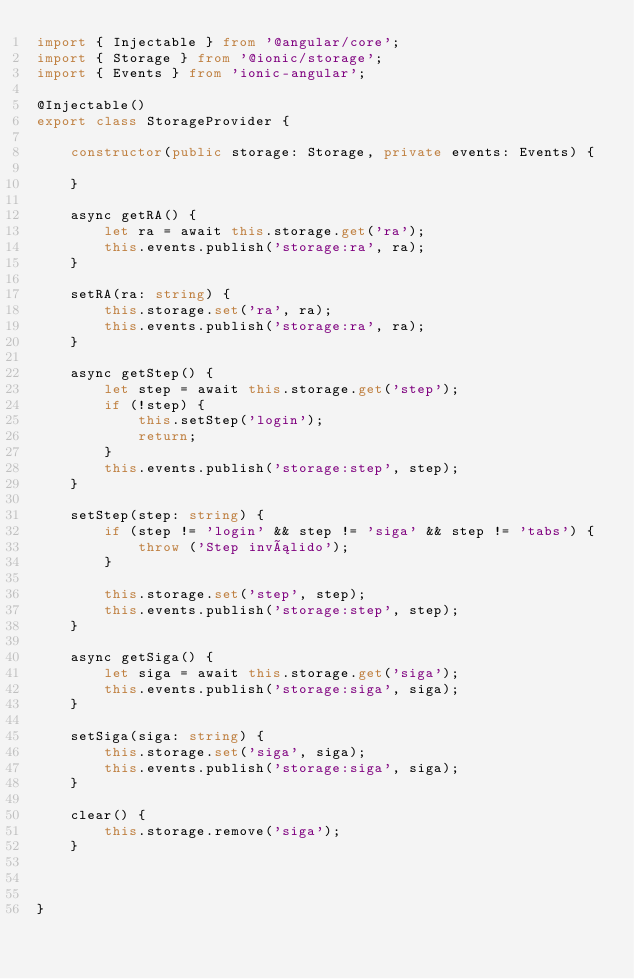<code> <loc_0><loc_0><loc_500><loc_500><_TypeScript_>import { Injectable } from '@angular/core';
import { Storage } from '@ionic/storage';
import { Events } from 'ionic-angular';

@Injectable()
export class StorageProvider {

    constructor(public storage: Storage, private events: Events) {

    }

    async getRA() {
        let ra = await this.storage.get('ra');
        this.events.publish('storage:ra', ra);
    }

    setRA(ra: string) {
        this.storage.set('ra', ra);
        this.events.publish('storage:ra', ra);
    }

    async getStep() {
        let step = await this.storage.get('step');
        if (!step) {
            this.setStep('login');
            return;
        }
        this.events.publish('storage:step', step);
    }

    setStep(step: string) {
        if (step != 'login' && step != 'siga' && step != 'tabs') {
            throw ('Step inválido');
        }

        this.storage.set('step', step);
        this.events.publish('storage:step', step);
    }

    async getSiga() {
        let siga = await this.storage.get('siga');
        this.events.publish('storage:siga', siga);
    }

    setSiga(siga: string) {
        this.storage.set('siga', siga);
        this.events.publish('storage:siga', siga);
    }

    clear() {
        this.storage.remove('siga');
    }



}
</code> 